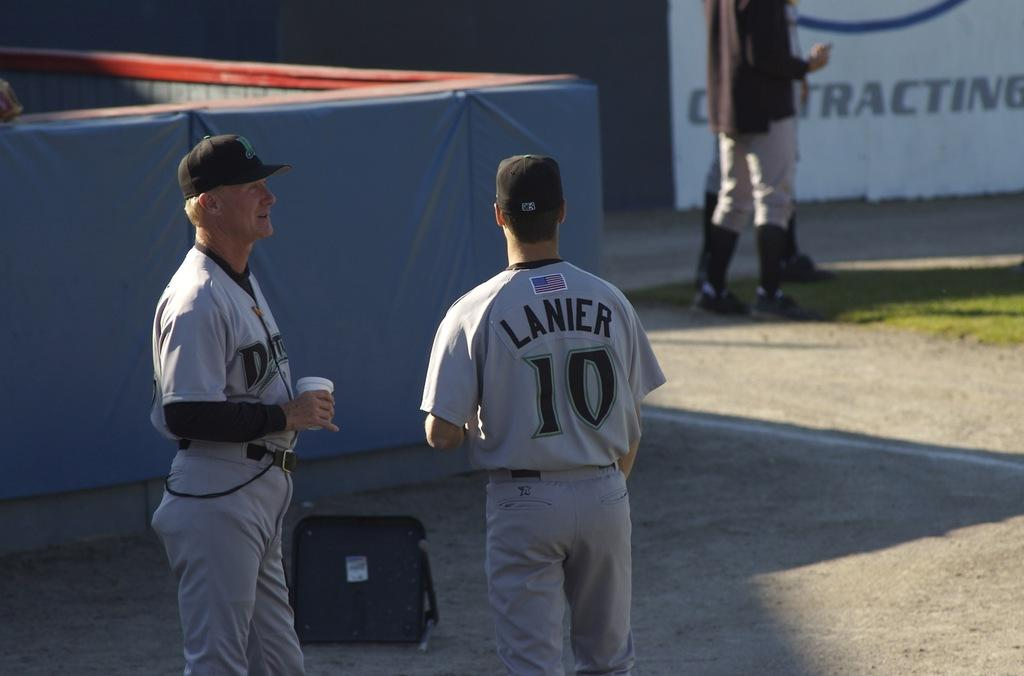<image>
Summarize the visual content of the image. The baseball player Lanier plays for an American team. 